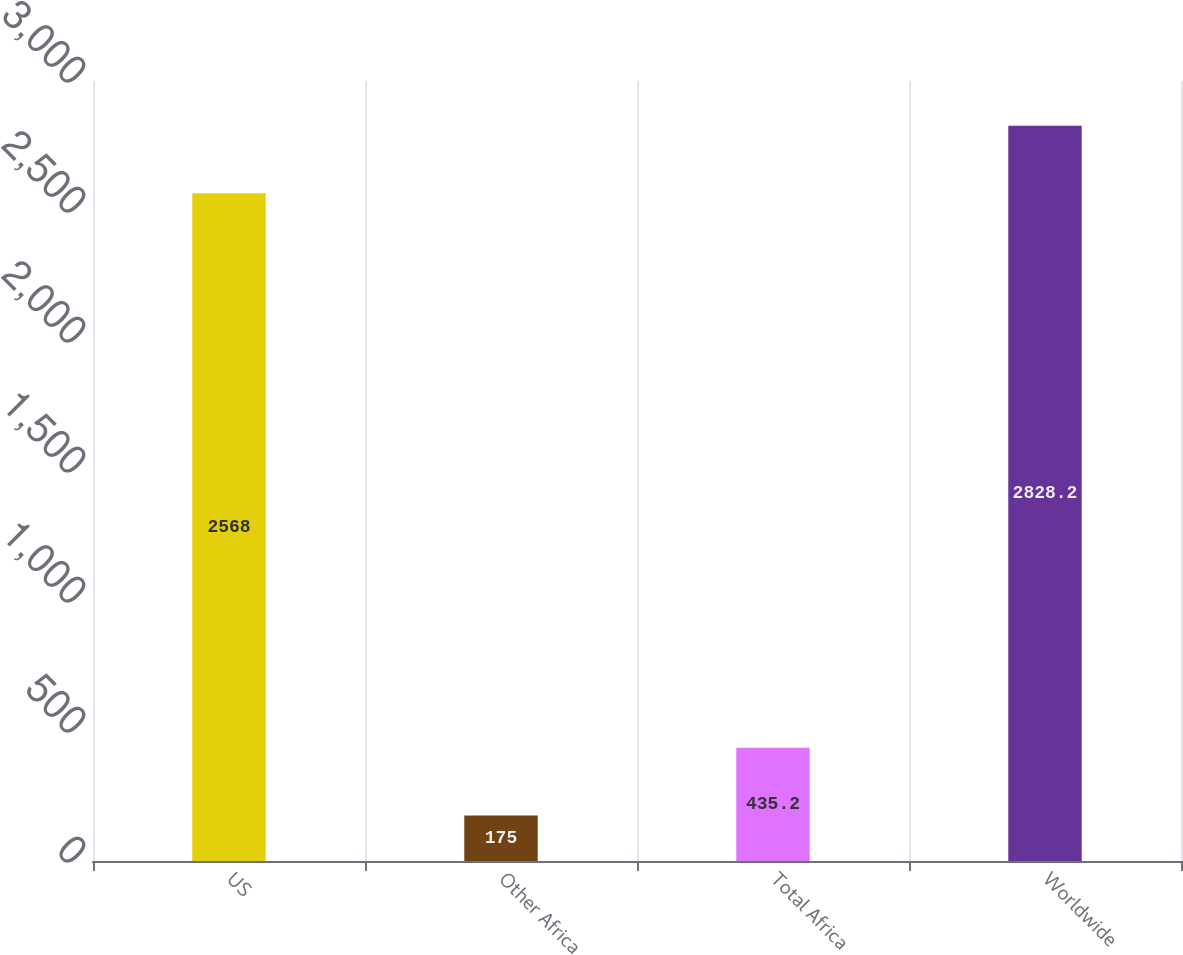Convert chart to OTSL. <chart><loc_0><loc_0><loc_500><loc_500><bar_chart><fcel>US<fcel>Other Africa<fcel>Total Africa<fcel>Worldwide<nl><fcel>2568<fcel>175<fcel>435.2<fcel>2828.2<nl></chart> 